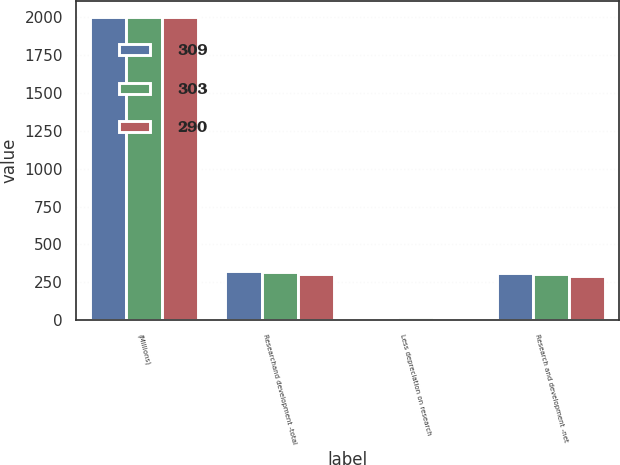Convert chart to OTSL. <chart><loc_0><loc_0><loc_500><loc_500><stacked_bar_chart><ecel><fcel>(Millions)<fcel>Researchand development -total<fcel>Less depreciation on research<fcel>Research and development -net<nl><fcel>309<fcel>2005<fcel>325<fcel>16<fcel>309<nl><fcel>303<fcel>2004<fcel>321<fcel>18<fcel>303<nl><fcel>290<fcel>2003<fcel>306<fcel>16<fcel>290<nl></chart> 